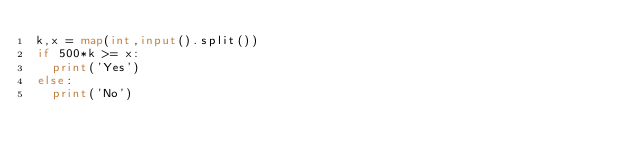Convert code to text. <code><loc_0><loc_0><loc_500><loc_500><_Python_>k,x = map(int,input().split())
if 500*k >= x:
  print('Yes')
else:
  print('No')</code> 